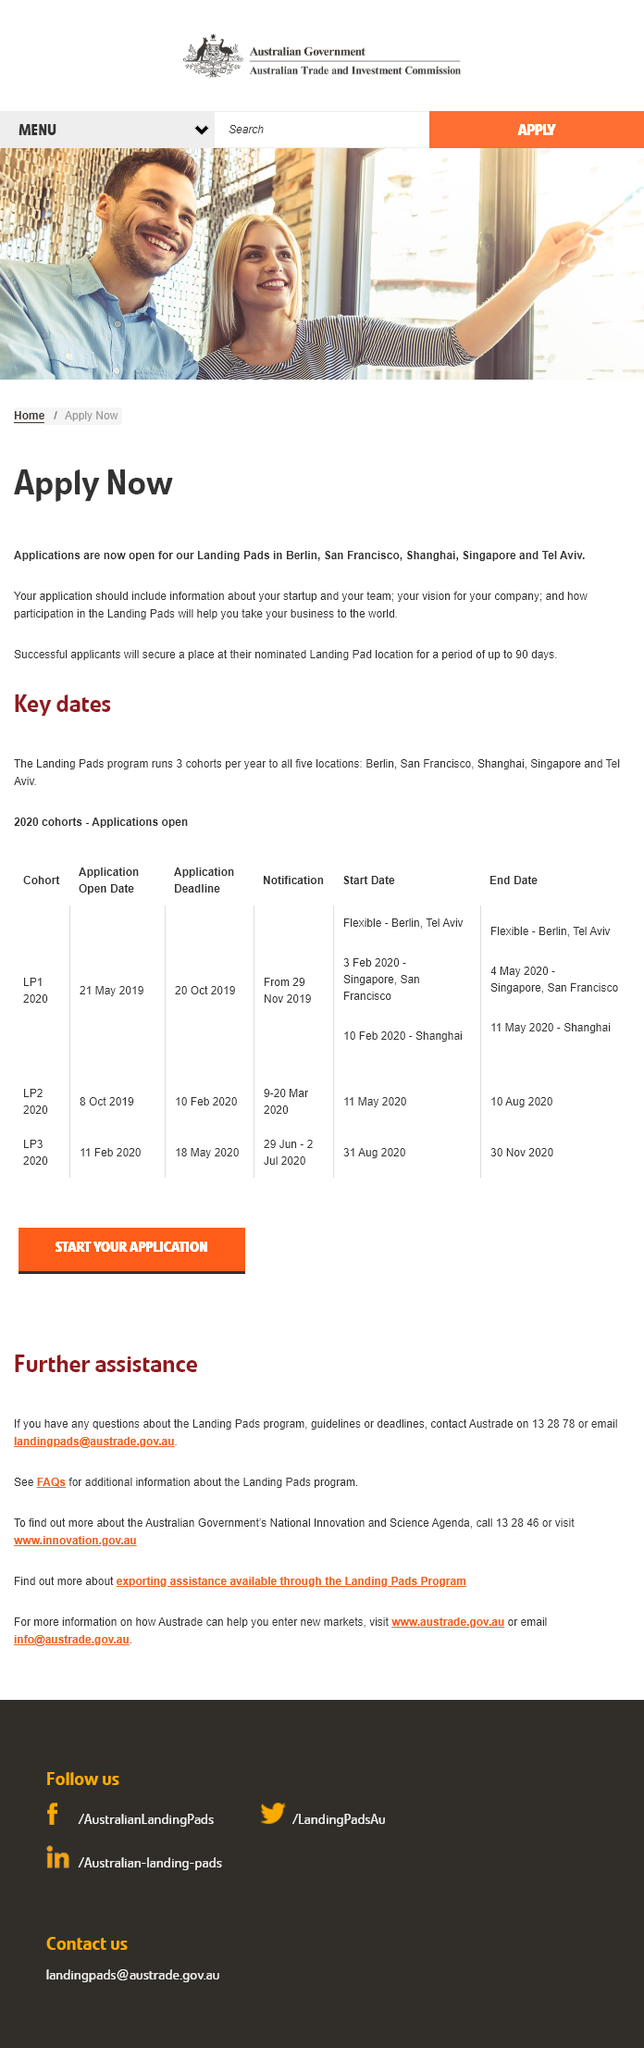Specify some key components in this picture. Your application should provide comprehensive information about your startup, including details about your team, your company's vision, and how participation in the Landing Pads program will contribute to the growth and success of your business. Landing Pads are currently accepting applications in Berlin, San Francisco, Shanghai, Singapore, and Tel Aviv. Successful applicants will be granted a place at their selected Landing Pad location for a period of up to 90 days as part of the program. 